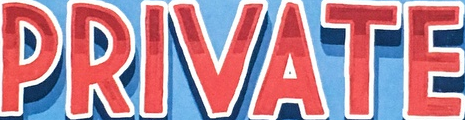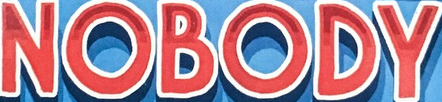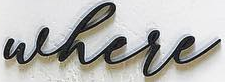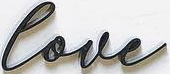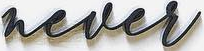Identify the words shown in these images in order, separated by a semicolon. PRIVATE; NOBODY; where; love; never 